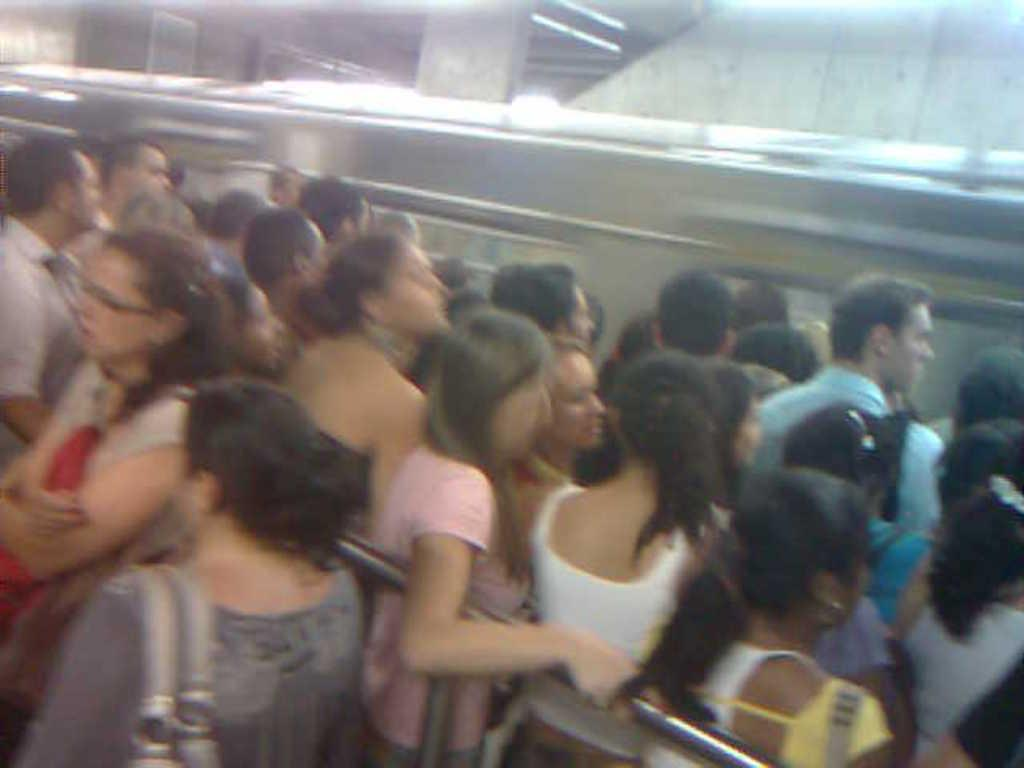How many people can be seen in the image? There are many people standing in the image. What is the main mode of transportation in the image? There is a train in the image. Can you describe any structures or objects attached to a wall in the image? There is a board attached to a wall in the image. How many pillars are visible in the image? There are two pillars in the image. What are some people holding in the image? Some people are holding objects in the image. Can you describe the woman in the image and what she is holding? There is a woman holding a pole in the image. How many light bulbs are visible in the image? There are no light bulbs present in the image. What type of vacation is being taken by the people in the image? There is no indication of a vacation in the image; it features a train and people standing near it. 